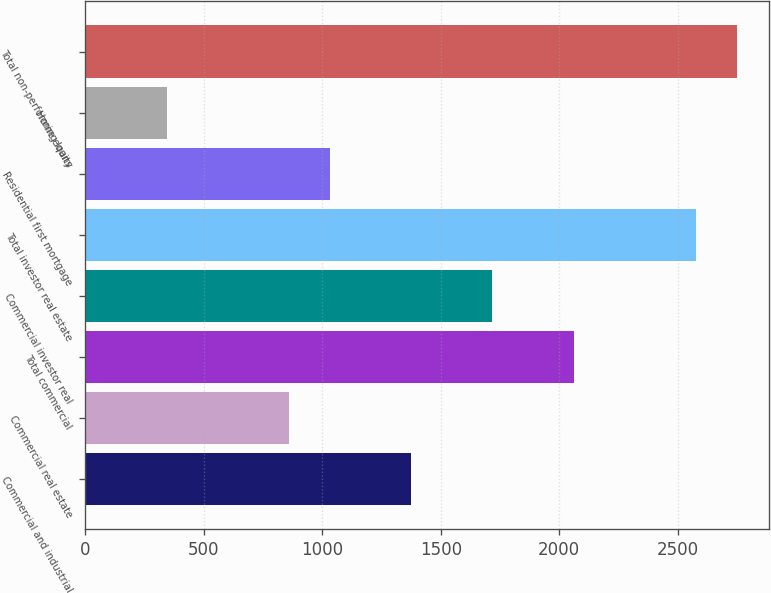Convert chart to OTSL. <chart><loc_0><loc_0><loc_500><loc_500><bar_chart><fcel>Commercial and industrial<fcel>Commercial real estate<fcel>Total commercial<fcel>Commercial investor real<fcel>Total investor real estate<fcel>Residential first mortgage<fcel>Home equity<fcel>Total non-performing loans<nl><fcel>1374.71<fcel>859.76<fcel>2061.31<fcel>1718.01<fcel>2576.26<fcel>1031.41<fcel>344.81<fcel>2747.91<nl></chart> 